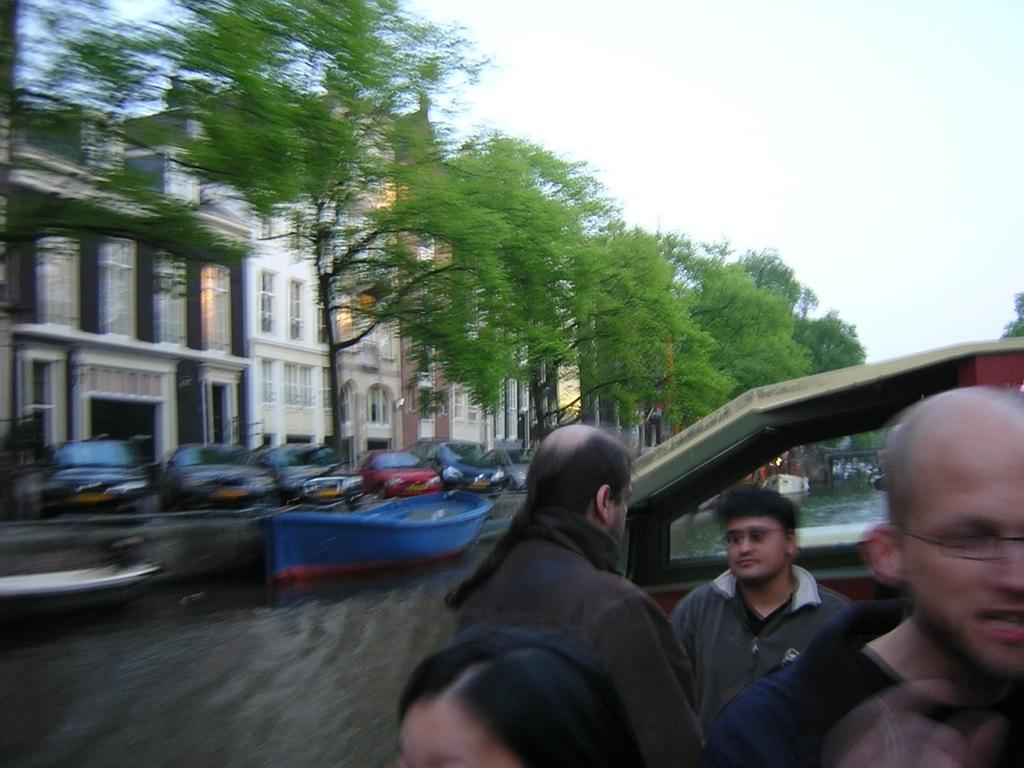What type of structures can be seen in the image? There are buildings in the image. What feature do the buildings have? The buildings have windows. What other natural elements are present in the image? There are trees in the image. What mode of transportation can be seen in the image? There are vehicles in the image. What part of the natural environment is visible in the image? The sky is visible in the image. What is present on the water surface in the image? There are boats on the water surface in the image. Are there any living beings visible in the image? Yes, there are people visible in the image. What type of fiction is being read by the kitten in the image? There is no kitten present in the image, and therefore no such activity can be observed. What kind of band is playing in the background of the image? There is no band present in the image; it features buildings, trees, vehicles, boats, and people. 